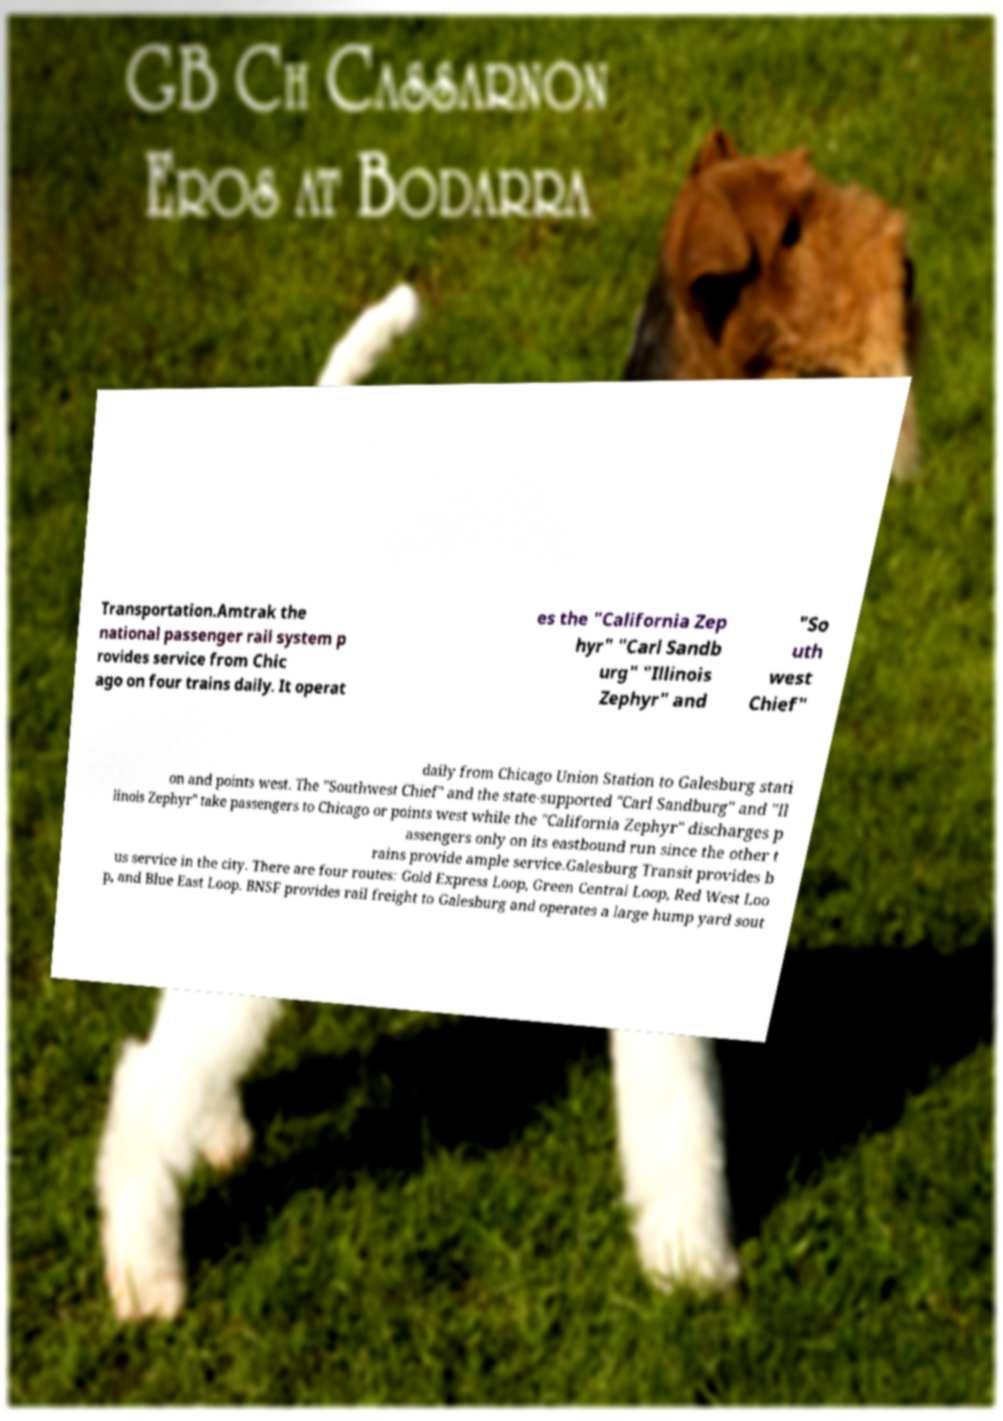I need the written content from this picture converted into text. Can you do that? Transportation.Amtrak the national passenger rail system p rovides service from Chic ago on four trains daily. It operat es the "California Zep hyr" "Carl Sandb urg" "Illinois Zephyr" and "So uth west Chief" daily from Chicago Union Station to Galesburg stati on and points west. The "Southwest Chief" and the state-supported "Carl Sandburg" and "Il linois Zephyr" take passengers to Chicago or points west while the "California Zephyr" discharges p assengers only on its eastbound run since the other t rains provide ample service.Galesburg Transit provides b us service in the city. There are four routes: Gold Express Loop, Green Central Loop, Red West Loo p, and Blue East Loop. BNSF provides rail freight to Galesburg and operates a large hump yard sout 